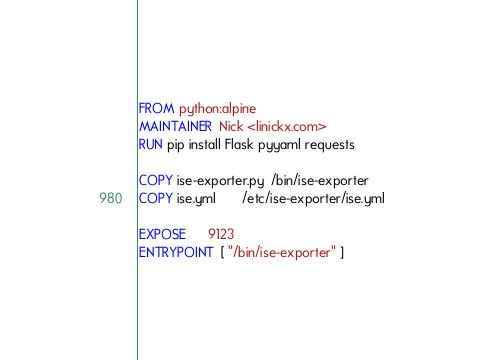<code> <loc_0><loc_0><loc_500><loc_500><_Dockerfile_>FROM python:alpine
MAINTAINER  Nick <linickx.com>
RUN pip install Flask pyyaml requests

COPY ise-exporter.py  /bin/ise-exporter
COPY ise.yml       /etc/ise-exporter/ise.yml

EXPOSE      9123
ENTRYPOINT  [ "/bin/ise-exporter" ]
</code> 